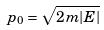Convert formula to latex. <formula><loc_0><loc_0><loc_500><loc_500>p _ { 0 } = \sqrt { 2 m | E | }</formula> 